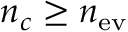<formula> <loc_0><loc_0><loc_500><loc_500>n _ { c } \geq n _ { e v }</formula> 